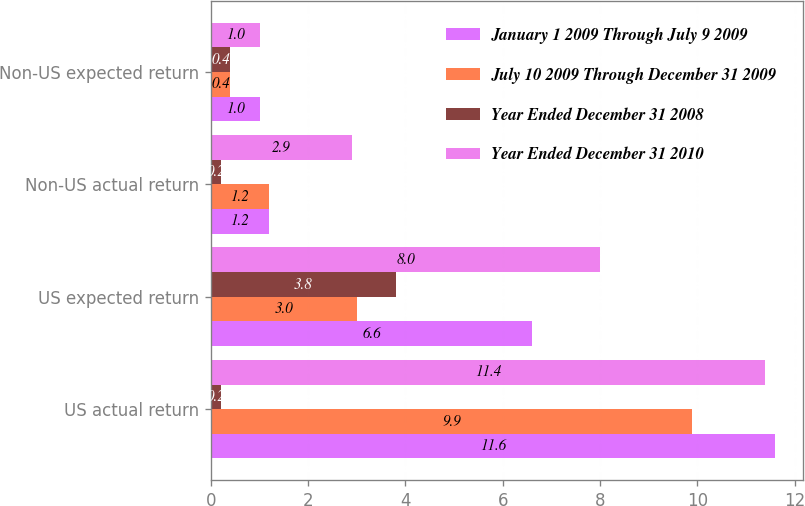<chart> <loc_0><loc_0><loc_500><loc_500><stacked_bar_chart><ecel><fcel>US actual return<fcel>US expected return<fcel>Non-US actual return<fcel>Non-US expected return<nl><fcel>January 1 2009 Through July 9 2009<fcel>11.6<fcel>6.6<fcel>1.2<fcel>1<nl><fcel>July 10 2009 Through December 31 2009<fcel>9.9<fcel>3<fcel>1.2<fcel>0.4<nl><fcel>Year Ended December 31 2008<fcel>0.2<fcel>3.8<fcel>0.2<fcel>0.4<nl><fcel>Year Ended December 31 2010<fcel>11.4<fcel>8<fcel>2.9<fcel>1<nl></chart> 